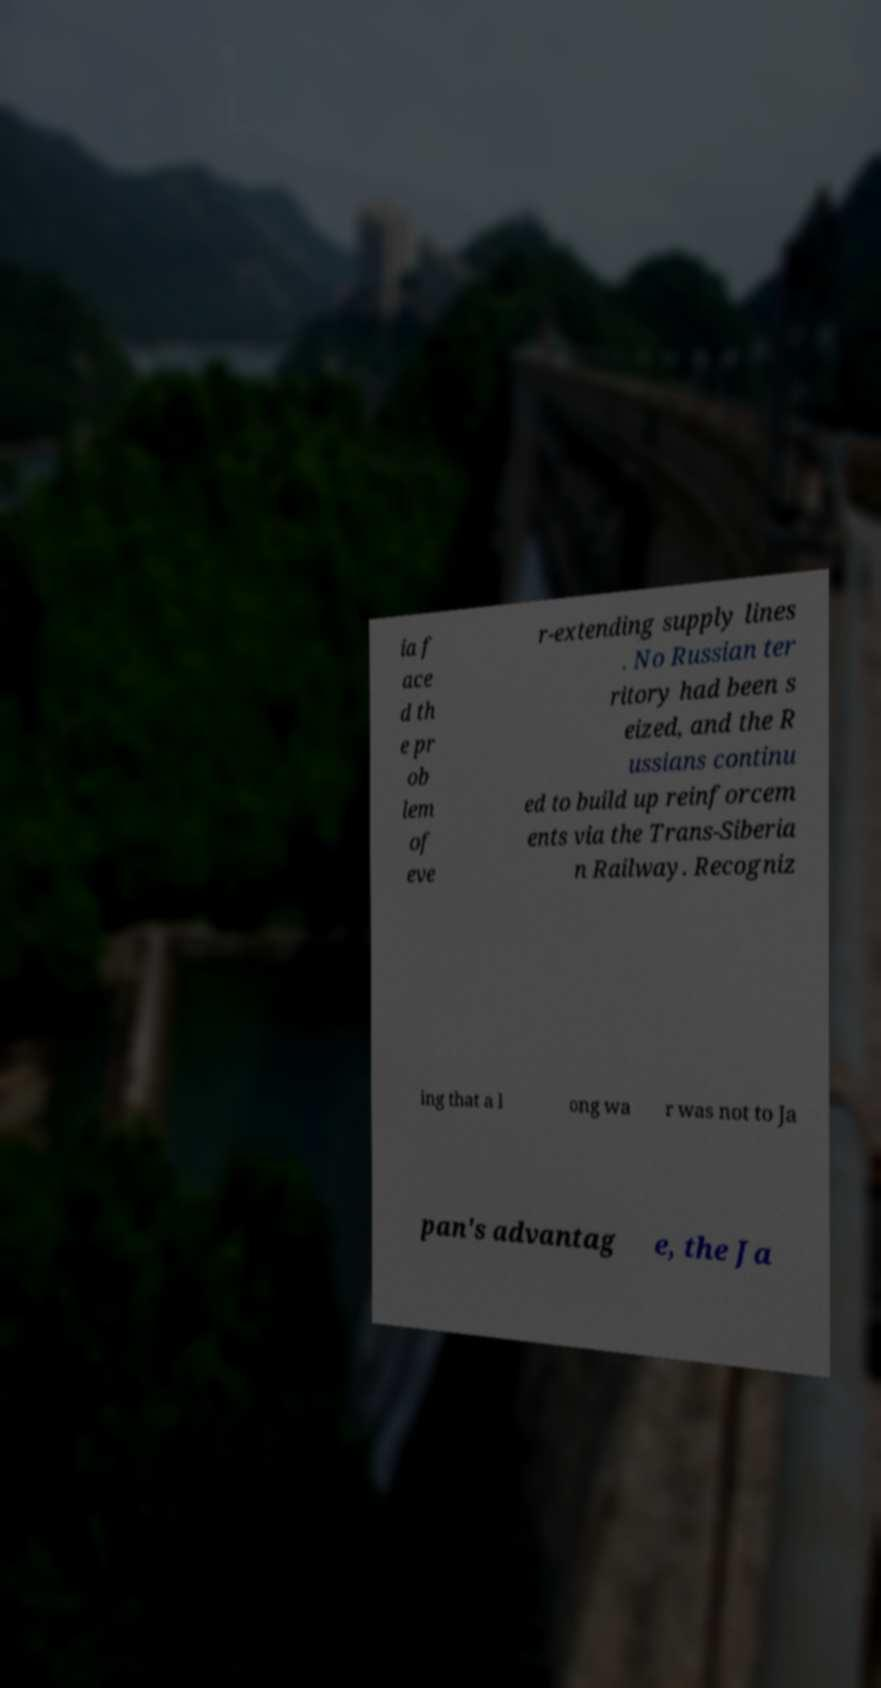Could you extract and type out the text from this image? ia f ace d th e pr ob lem of eve r-extending supply lines . No Russian ter ritory had been s eized, and the R ussians continu ed to build up reinforcem ents via the Trans-Siberia n Railway. Recogniz ing that a l ong wa r was not to Ja pan's advantag e, the Ja 